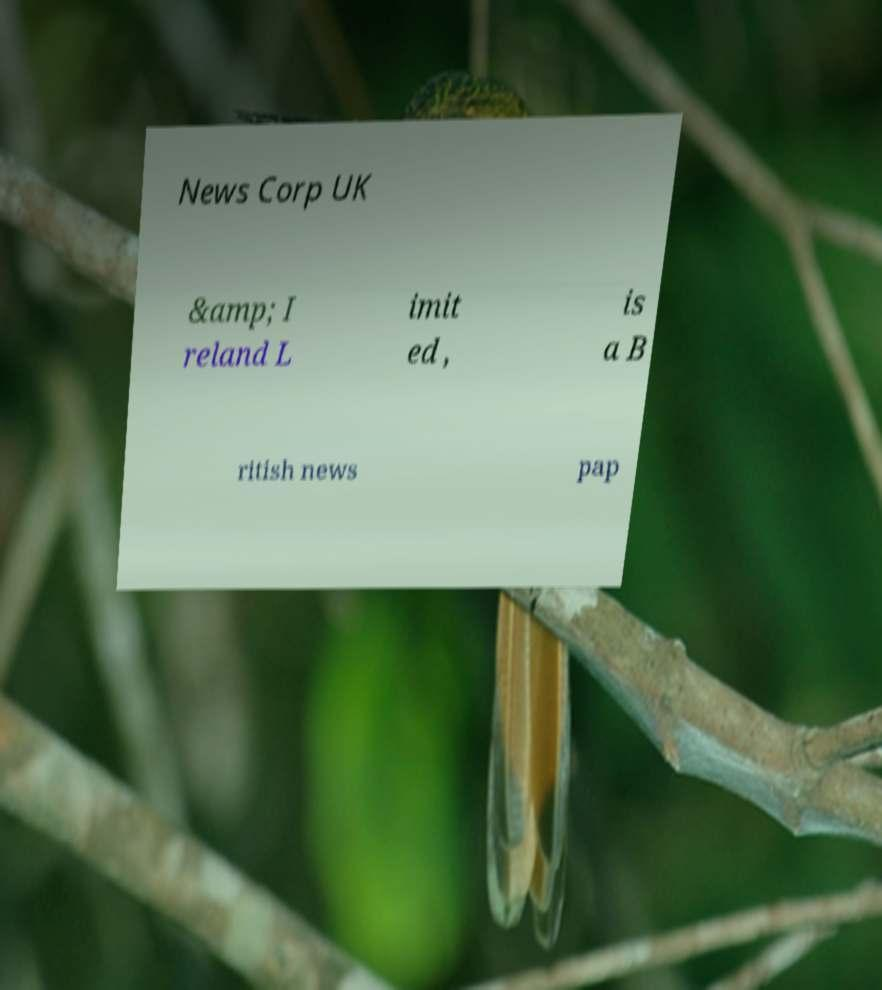Please identify and transcribe the text found in this image. News Corp UK &amp; I reland L imit ed , is a B ritish news pap 